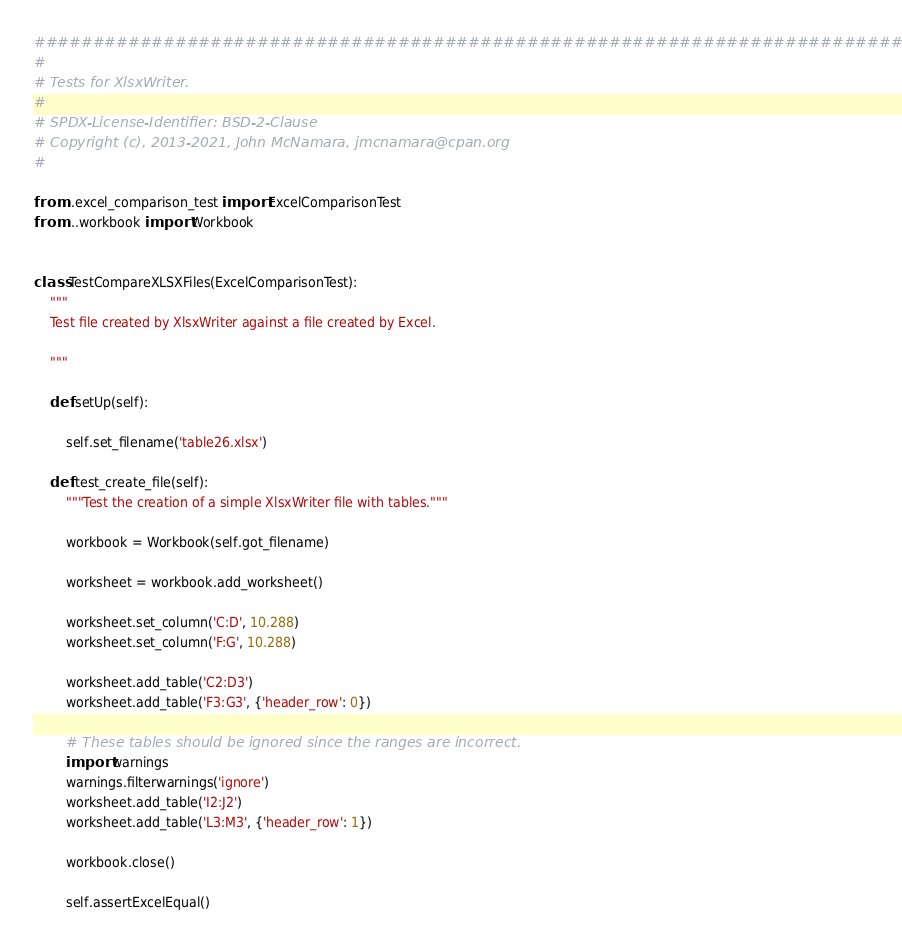<code> <loc_0><loc_0><loc_500><loc_500><_Python_>###############################################################################
#
# Tests for XlsxWriter.
#
# SPDX-License-Identifier: BSD-2-Clause
# Copyright (c), 2013-2021, John McNamara, jmcnamara@cpan.org
#

from ..excel_comparison_test import ExcelComparisonTest
from ...workbook import Workbook


class TestCompareXLSXFiles(ExcelComparisonTest):
    """
    Test file created by XlsxWriter against a file created by Excel.

    """

    def setUp(self):

        self.set_filename('table26.xlsx')

    def test_create_file(self):
        """Test the creation of a simple XlsxWriter file with tables."""

        workbook = Workbook(self.got_filename)

        worksheet = workbook.add_worksheet()

        worksheet.set_column('C:D', 10.288)
        worksheet.set_column('F:G', 10.288)

        worksheet.add_table('C2:D3')
        worksheet.add_table('F3:G3', {'header_row': 0})

        # These tables should be ignored since the ranges are incorrect.
        import warnings
        warnings.filterwarnings('ignore')
        worksheet.add_table('I2:J2')
        worksheet.add_table('L3:M3', {'header_row': 1})

        workbook.close()

        self.assertExcelEqual()
</code> 